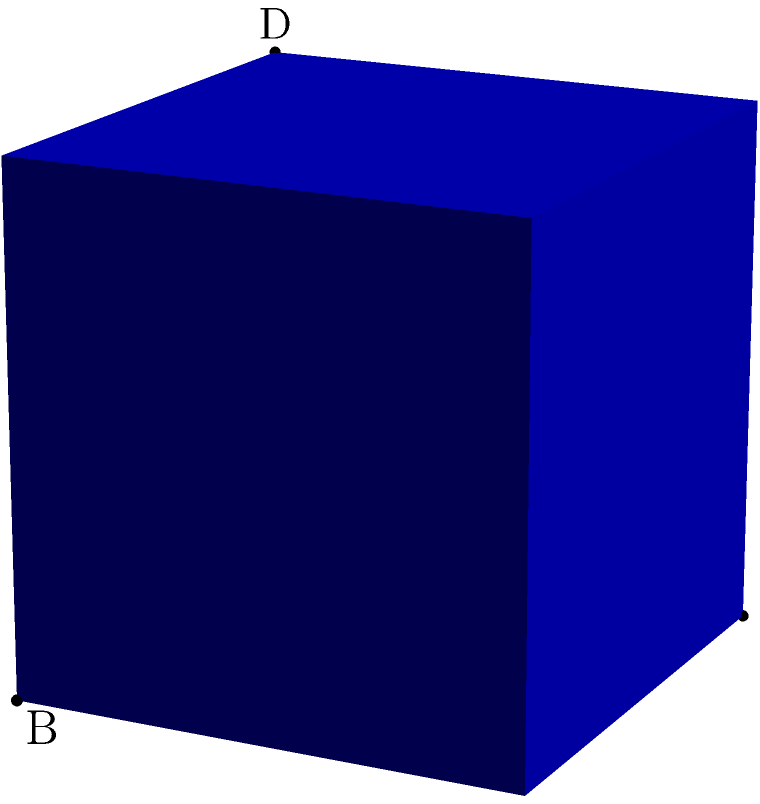Imagine Jessamy Stoddart is explaining geometric concepts in her latest performance. She describes a regular tetrahedron with an edge length of 6 cm. What would be the total surface area of this tetrahedron? Let's approach this step-by-step:

1) A regular tetrahedron has four congruent equilateral triangular faces.

2) To find the total surface area, we need to calculate the area of one face and multiply it by 4.

3) The area of an equilateral triangle is given by the formula:
   $A = \frac{\sqrt{3}}{4}a^2$, where $a$ is the side length.

4) In this case, $a = 6$ cm.

5) Let's substitute this into our formula:
   $A = \frac{\sqrt{3}}{4}(6^2) = \frac{\sqrt{3}}{4}(36) = 9\sqrt{3}$ cm²

6) This is the area of one face. To get the total surface area, we multiply by 4:
   Total Surface Area $= 4(9\sqrt{3}) = 36\sqrt{3}$ cm²

Therefore, the total surface area of the tetrahedron is $36\sqrt{3}$ cm².
Answer: $36\sqrt{3}$ cm² 